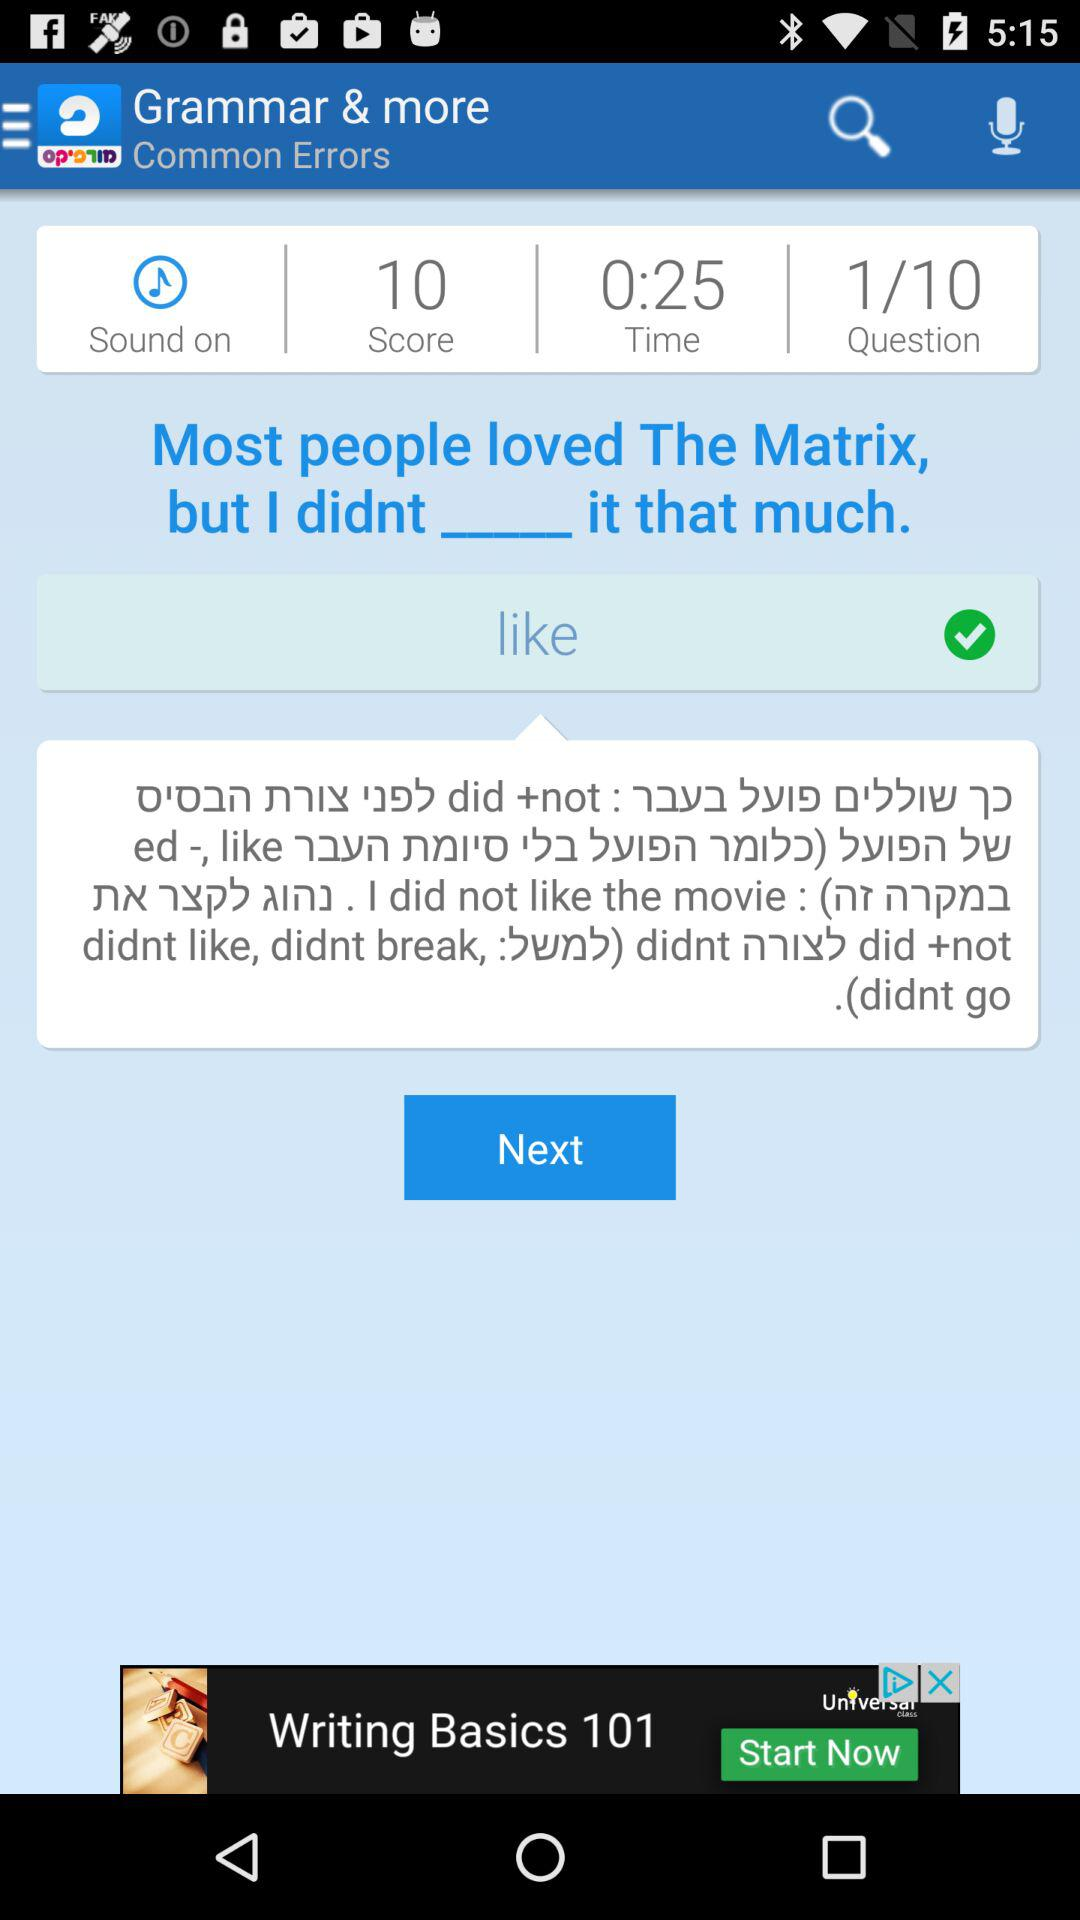What is the status of sound? The status of sound is "on". 